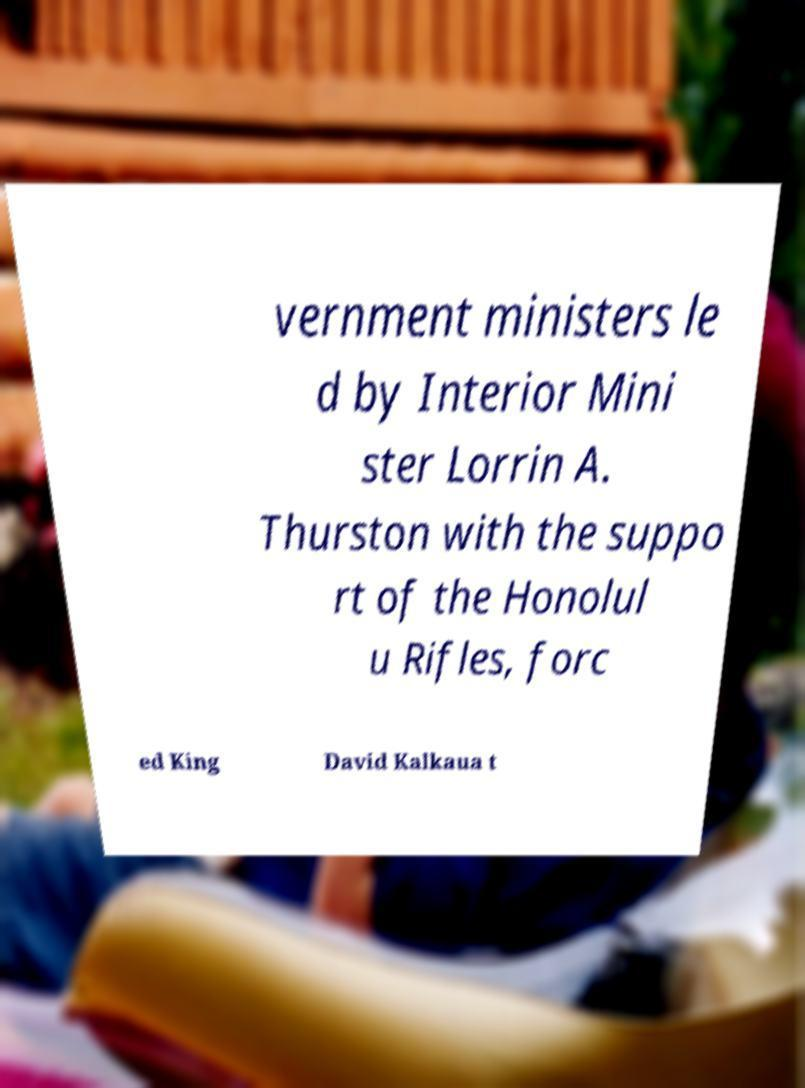What messages or text are displayed in this image? I need them in a readable, typed format. vernment ministers le d by Interior Mini ster Lorrin A. Thurston with the suppo rt of the Honolul u Rifles, forc ed King David Kalkaua t 